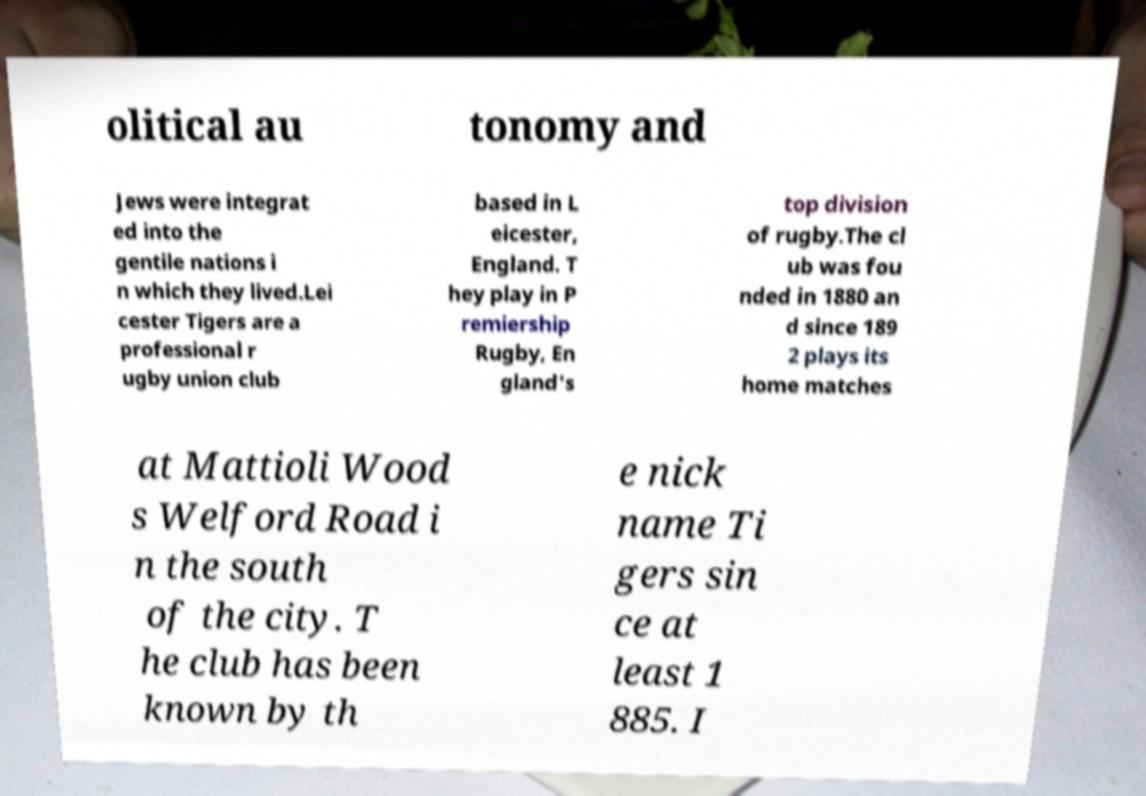Could you extract and type out the text from this image? olitical au tonomy and Jews were integrat ed into the gentile nations i n which they lived.Lei cester Tigers are a professional r ugby union club based in L eicester, England. T hey play in P remiership Rugby, En gland's top division of rugby.The cl ub was fou nded in 1880 an d since 189 2 plays its home matches at Mattioli Wood s Welford Road i n the south of the city. T he club has been known by th e nick name Ti gers sin ce at least 1 885. I 